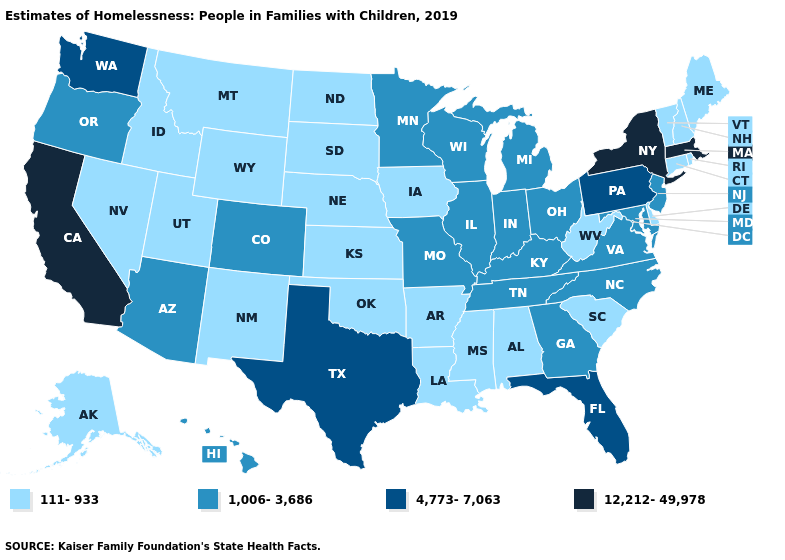What is the value of Iowa?
Write a very short answer. 111-933. Name the states that have a value in the range 12,212-49,978?
Give a very brief answer. California, Massachusetts, New York. Name the states that have a value in the range 111-933?
Concise answer only. Alabama, Alaska, Arkansas, Connecticut, Delaware, Idaho, Iowa, Kansas, Louisiana, Maine, Mississippi, Montana, Nebraska, Nevada, New Hampshire, New Mexico, North Dakota, Oklahoma, Rhode Island, South Carolina, South Dakota, Utah, Vermont, West Virginia, Wyoming. Does New Mexico have the highest value in the USA?
Short answer required. No. Name the states that have a value in the range 12,212-49,978?
Be succinct. California, Massachusetts, New York. What is the lowest value in the MidWest?
Give a very brief answer. 111-933. Name the states that have a value in the range 1,006-3,686?
Answer briefly. Arizona, Colorado, Georgia, Hawaii, Illinois, Indiana, Kentucky, Maryland, Michigan, Minnesota, Missouri, New Jersey, North Carolina, Ohio, Oregon, Tennessee, Virginia, Wisconsin. Does Massachusetts have the highest value in the USA?
Keep it brief. Yes. Does Oklahoma have the same value as Ohio?
Give a very brief answer. No. What is the lowest value in states that border Mississippi?
Short answer required. 111-933. What is the value of California?
Concise answer only. 12,212-49,978. What is the value of Alabama?
Short answer required. 111-933. What is the lowest value in the USA?
Write a very short answer. 111-933. What is the value of New York?
Give a very brief answer. 12,212-49,978. Does the first symbol in the legend represent the smallest category?
Answer briefly. Yes. 